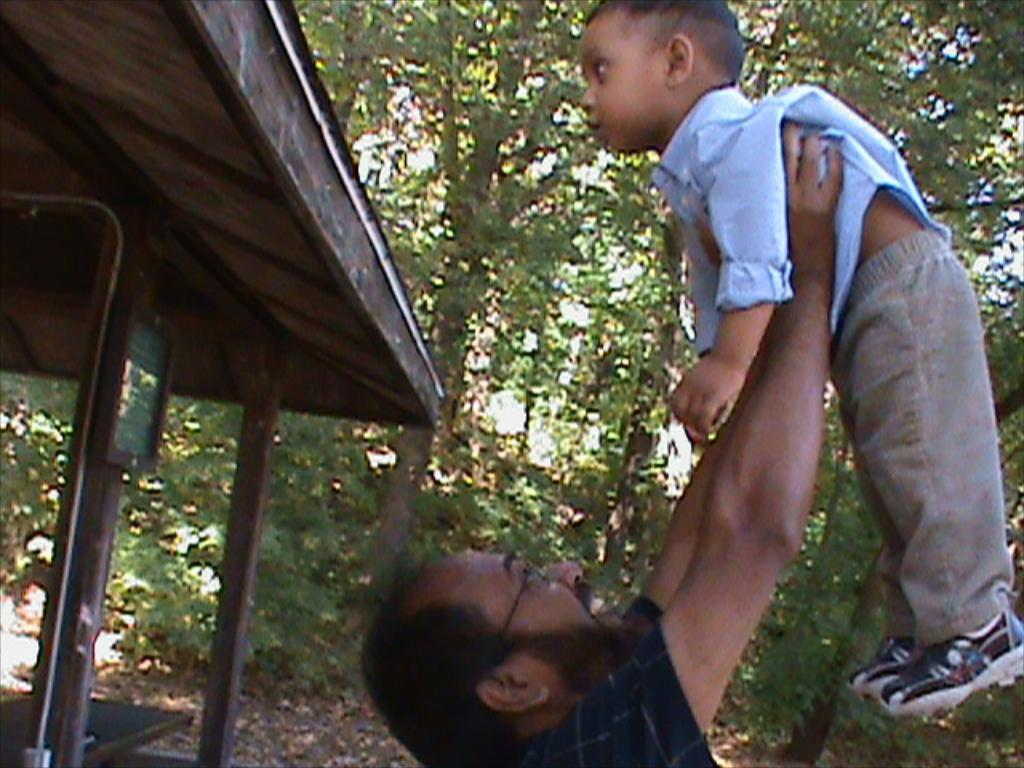How many people are in the image? There are two people in the image. What are the people wearing? The people are wearing different color dresses. What can be seen on the left side of the image? There is a board attached to a shed on the left side of the image. What is visible in the background of the image? There are many trees and the sky in the background of the image. What direction is the wind blowing in the image? There is no indication of wind in the image, so it cannot be determined from the image. What is the cause of the people wearing different color dresses in the image? The image does not provide any information about the reason for the people wearing different color dresses, so it cannot be determined from the image. 